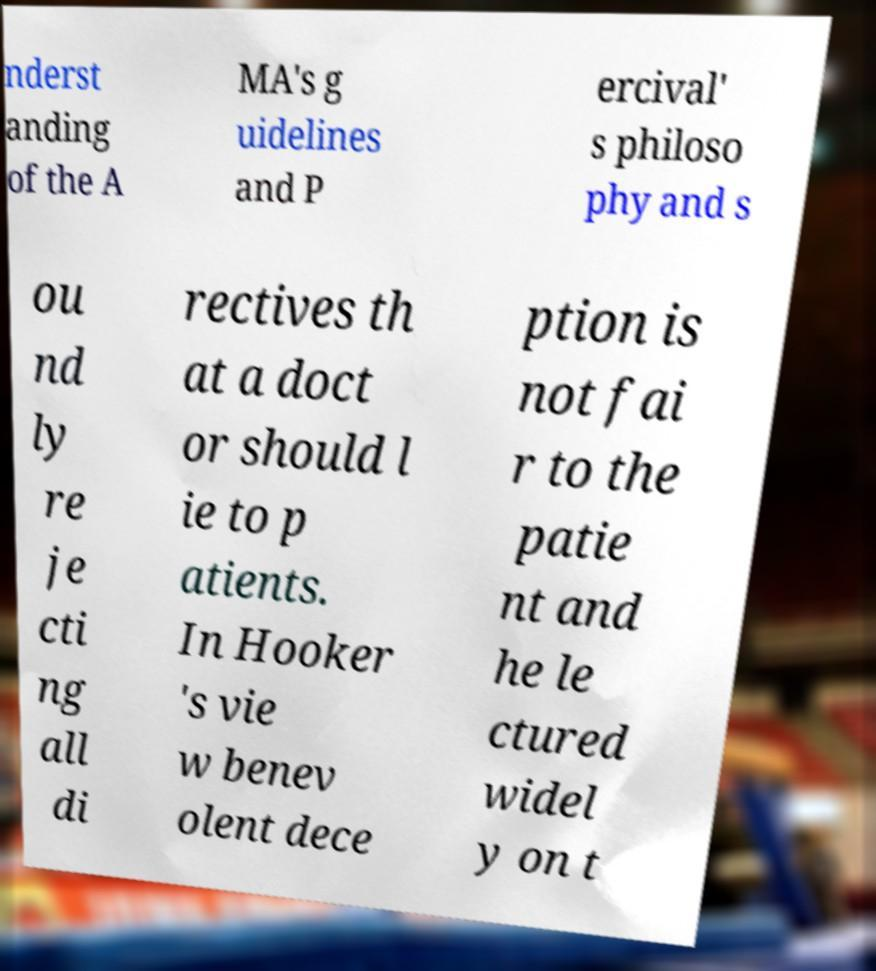Could you assist in decoding the text presented in this image and type it out clearly? nderst anding of the A MA's g uidelines and P ercival' s philoso phy and s ou nd ly re je cti ng all di rectives th at a doct or should l ie to p atients. In Hooker 's vie w benev olent dece ption is not fai r to the patie nt and he le ctured widel y on t 